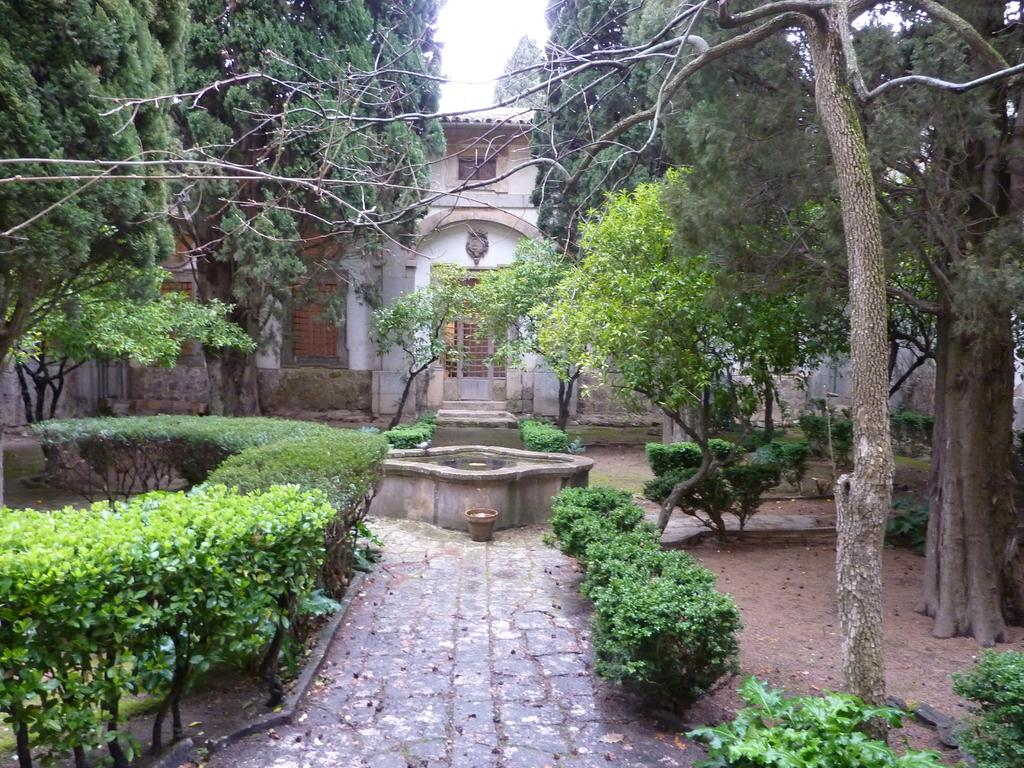What type of vegetation can be seen in the image? There are plants and trees in the image. Can you describe the structure visible in the background? There is a house in the background of the image. What type of crown is worn by the tree in the image? There is no crown present in the image, as trees do not wear crowns. 